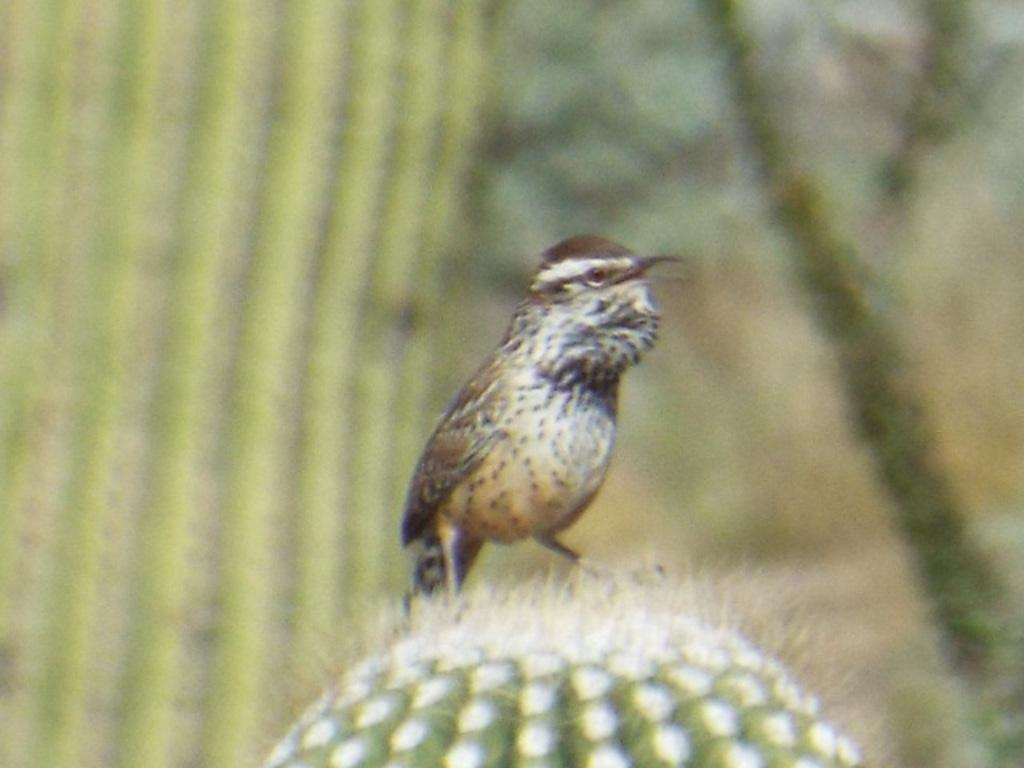What is the main subject of the image? There is a bird in the center of the image. Can you describe the background of the image? The background area of the image is blurred. What type of winter print can be seen on the bird's thumb in the image? There is no reference to winter or a print on the bird's thumb in the image, as it only features a bird with a blurred background. 